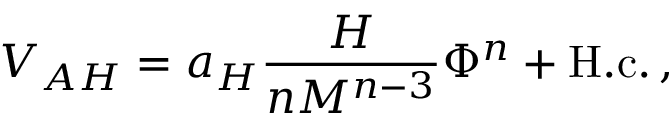Convert formula to latex. <formula><loc_0><loc_0><loc_500><loc_500>V _ { A H } = a _ { H } \frac { H } { n M ^ { n - 3 } } \Phi ^ { n } + H . c . \, ,</formula> 